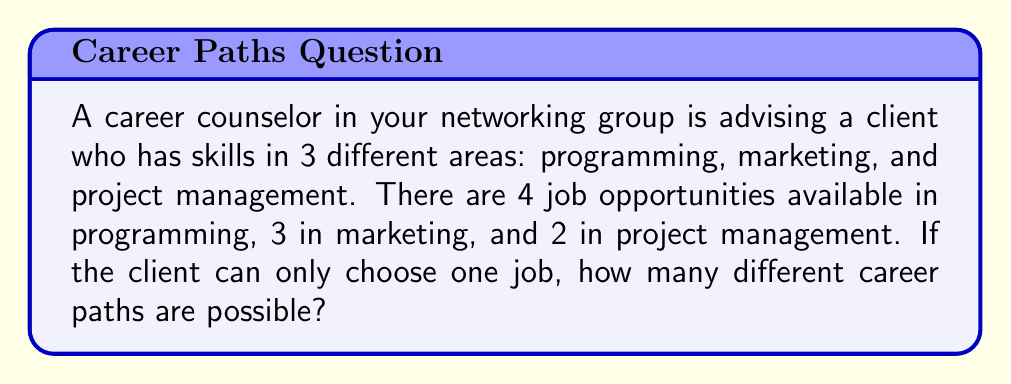Show me your answer to this math problem. Let's approach this step-by-step using the addition principle of counting:

1) First, let's identify the sets of choices:
   - Programming jobs: 4 choices
   - Marketing jobs: 3 choices
   - Project management jobs: 2 choices

2) The client can only choose one job, which means they must select from one of these sets.

3) According to the addition principle, when we have mutually exclusive events (in this case, the client can only choose one job type), we add the number of possibilities for each event.

4) Therefore, the total number of possible career paths is:

   $$ \text{Total paths} = \text{Programming jobs} + \text{Marketing jobs} + \text{Project management jobs} $$

5) Substituting the values:

   $$ \text{Total paths} = 4 + 3 + 2 $$

6) Calculating the sum:

   $$ \text{Total paths} = 9 $$

Thus, there are 9 different career paths possible for the client.
Answer: 9 